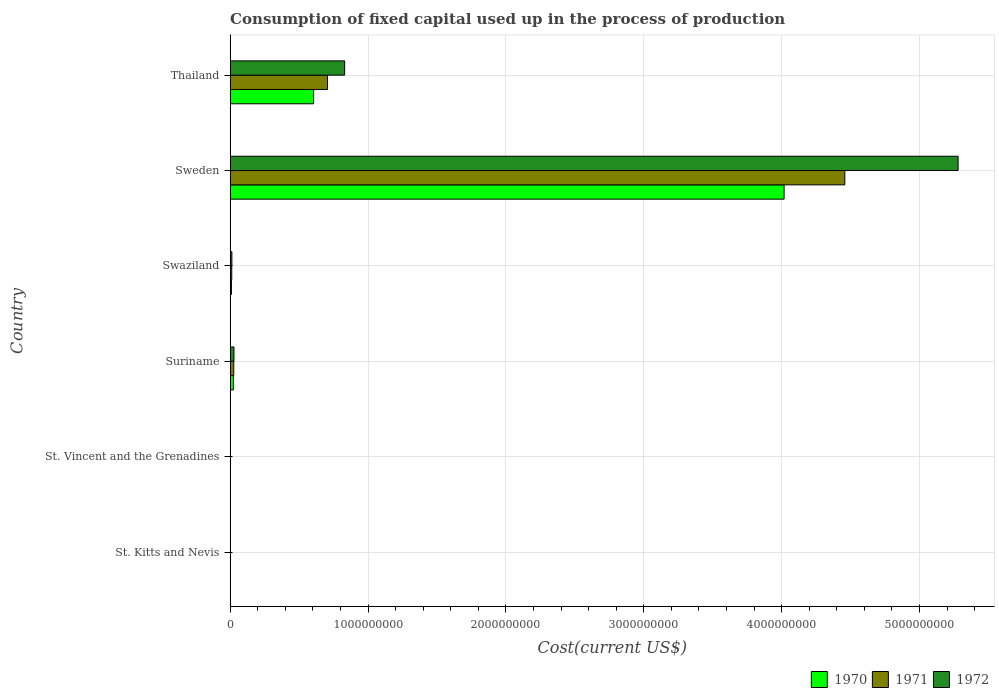How many different coloured bars are there?
Ensure brevity in your answer.  3. How many groups of bars are there?
Your response must be concise. 6. Are the number of bars per tick equal to the number of legend labels?
Give a very brief answer. Yes. Are the number of bars on each tick of the Y-axis equal?
Ensure brevity in your answer.  Yes. How many bars are there on the 6th tick from the top?
Make the answer very short. 3. What is the label of the 6th group of bars from the top?
Provide a short and direct response. St. Kitts and Nevis. What is the amount consumed in the process of production in 1971 in St. Kitts and Nevis?
Give a very brief answer. 1.05e+06. Across all countries, what is the maximum amount consumed in the process of production in 1971?
Your answer should be compact. 4.46e+09. Across all countries, what is the minimum amount consumed in the process of production in 1971?
Offer a terse response. 4.77e+05. In which country was the amount consumed in the process of production in 1970 minimum?
Your answer should be compact. St. Kitts and Nevis. What is the total amount consumed in the process of production in 1972 in the graph?
Keep it short and to the point. 6.15e+09. What is the difference between the amount consumed in the process of production in 1970 in Suriname and that in Sweden?
Offer a terse response. -3.99e+09. What is the difference between the amount consumed in the process of production in 1972 in St. Kitts and Nevis and the amount consumed in the process of production in 1971 in Swaziland?
Provide a short and direct response. -9.95e+06. What is the average amount consumed in the process of production in 1970 per country?
Your answer should be very brief. 7.76e+08. What is the difference between the amount consumed in the process of production in 1972 and amount consumed in the process of production in 1971 in Suriname?
Your answer should be compact. 1.60e+06. In how many countries, is the amount consumed in the process of production in 1970 greater than 600000000 US$?
Your answer should be very brief. 2. What is the ratio of the amount consumed in the process of production in 1970 in St. Kitts and Nevis to that in Sweden?
Give a very brief answer. 0. What is the difference between the highest and the second highest amount consumed in the process of production in 1972?
Your answer should be compact. 4.45e+09. What is the difference between the highest and the lowest amount consumed in the process of production in 1972?
Your response must be concise. 5.28e+09. In how many countries, is the amount consumed in the process of production in 1970 greater than the average amount consumed in the process of production in 1970 taken over all countries?
Provide a short and direct response. 1. Is the sum of the amount consumed in the process of production in 1971 in St. Vincent and the Grenadines and Suriname greater than the maximum amount consumed in the process of production in 1972 across all countries?
Provide a short and direct response. No. How many countries are there in the graph?
Make the answer very short. 6. Are the values on the major ticks of X-axis written in scientific E-notation?
Give a very brief answer. No. Where does the legend appear in the graph?
Make the answer very short. Bottom right. How many legend labels are there?
Your answer should be compact. 3. How are the legend labels stacked?
Your response must be concise. Horizontal. What is the title of the graph?
Your answer should be compact. Consumption of fixed capital used up in the process of production. What is the label or title of the X-axis?
Your answer should be compact. Cost(current US$). What is the Cost(current US$) of 1970 in St. Kitts and Nevis?
Provide a succinct answer. 8.25e+05. What is the Cost(current US$) of 1971 in St. Kitts and Nevis?
Provide a short and direct response. 1.05e+06. What is the Cost(current US$) in 1972 in St. Kitts and Nevis?
Make the answer very short. 1.35e+06. What is the Cost(current US$) of 1970 in St. Vincent and the Grenadines?
Offer a terse response. 9.66e+05. What is the Cost(current US$) of 1971 in St. Vincent and the Grenadines?
Give a very brief answer. 4.77e+05. What is the Cost(current US$) in 1972 in St. Vincent and the Grenadines?
Provide a short and direct response. 5.25e+05. What is the Cost(current US$) of 1970 in Suriname?
Offer a terse response. 2.35e+07. What is the Cost(current US$) of 1971 in Suriname?
Ensure brevity in your answer.  2.58e+07. What is the Cost(current US$) of 1972 in Suriname?
Make the answer very short. 2.74e+07. What is the Cost(current US$) in 1970 in Swaziland?
Your answer should be very brief. 9.10e+06. What is the Cost(current US$) of 1971 in Swaziland?
Give a very brief answer. 1.13e+07. What is the Cost(current US$) of 1972 in Swaziland?
Make the answer very short. 1.23e+07. What is the Cost(current US$) of 1970 in Sweden?
Ensure brevity in your answer.  4.02e+09. What is the Cost(current US$) in 1971 in Sweden?
Provide a succinct answer. 4.46e+09. What is the Cost(current US$) of 1972 in Sweden?
Keep it short and to the point. 5.28e+09. What is the Cost(current US$) in 1970 in Thailand?
Offer a very short reply. 6.05e+08. What is the Cost(current US$) of 1971 in Thailand?
Your answer should be very brief. 7.06e+08. What is the Cost(current US$) of 1972 in Thailand?
Make the answer very short. 8.30e+08. Across all countries, what is the maximum Cost(current US$) of 1970?
Give a very brief answer. 4.02e+09. Across all countries, what is the maximum Cost(current US$) of 1971?
Keep it short and to the point. 4.46e+09. Across all countries, what is the maximum Cost(current US$) in 1972?
Your answer should be compact. 5.28e+09. Across all countries, what is the minimum Cost(current US$) in 1970?
Provide a succinct answer. 8.25e+05. Across all countries, what is the minimum Cost(current US$) of 1971?
Offer a very short reply. 4.77e+05. Across all countries, what is the minimum Cost(current US$) in 1972?
Your answer should be very brief. 5.25e+05. What is the total Cost(current US$) of 1970 in the graph?
Keep it short and to the point. 4.66e+09. What is the total Cost(current US$) in 1971 in the graph?
Offer a very short reply. 5.20e+09. What is the total Cost(current US$) of 1972 in the graph?
Offer a very short reply. 6.15e+09. What is the difference between the Cost(current US$) of 1970 in St. Kitts and Nevis and that in St. Vincent and the Grenadines?
Give a very brief answer. -1.41e+05. What is the difference between the Cost(current US$) of 1971 in St. Kitts and Nevis and that in St. Vincent and the Grenadines?
Provide a succinct answer. 5.71e+05. What is the difference between the Cost(current US$) of 1972 in St. Kitts and Nevis and that in St. Vincent and the Grenadines?
Your answer should be compact. 8.24e+05. What is the difference between the Cost(current US$) of 1970 in St. Kitts and Nevis and that in Suriname?
Your answer should be very brief. -2.26e+07. What is the difference between the Cost(current US$) of 1971 in St. Kitts and Nevis and that in Suriname?
Keep it short and to the point. -2.48e+07. What is the difference between the Cost(current US$) in 1972 in St. Kitts and Nevis and that in Suriname?
Provide a succinct answer. -2.61e+07. What is the difference between the Cost(current US$) in 1970 in St. Kitts and Nevis and that in Swaziland?
Your answer should be very brief. -8.28e+06. What is the difference between the Cost(current US$) in 1971 in St. Kitts and Nevis and that in Swaziland?
Your answer should be compact. -1.03e+07. What is the difference between the Cost(current US$) of 1972 in St. Kitts and Nevis and that in Swaziland?
Make the answer very short. -1.09e+07. What is the difference between the Cost(current US$) of 1970 in St. Kitts and Nevis and that in Sweden?
Make the answer very short. -4.02e+09. What is the difference between the Cost(current US$) in 1971 in St. Kitts and Nevis and that in Sweden?
Your response must be concise. -4.46e+09. What is the difference between the Cost(current US$) in 1972 in St. Kitts and Nevis and that in Sweden?
Provide a short and direct response. -5.28e+09. What is the difference between the Cost(current US$) of 1970 in St. Kitts and Nevis and that in Thailand?
Make the answer very short. -6.04e+08. What is the difference between the Cost(current US$) of 1971 in St. Kitts and Nevis and that in Thailand?
Make the answer very short. -7.05e+08. What is the difference between the Cost(current US$) of 1972 in St. Kitts and Nevis and that in Thailand?
Offer a terse response. -8.29e+08. What is the difference between the Cost(current US$) in 1970 in St. Vincent and the Grenadines and that in Suriname?
Make the answer very short. -2.25e+07. What is the difference between the Cost(current US$) in 1971 in St. Vincent and the Grenadines and that in Suriname?
Provide a short and direct response. -2.53e+07. What is the difference between the Cost(current US$) in 1972 in St. Vincent and the Grenadines and that in Suriname?
Keep it short and to the point. -2.69e+07. What is the difference between the Cost(current US$) in 1970 in St. Vincent and the Grenadines and that in Swaziland?
Your response must be concise. -8.14e+06. What is the difference between the Cost(current US$) of 1971 in St. Vincent and the Grenadines and that in Swaziland?
Make the answer very short. -1.08e+07. What is the difference between the Cost(current US$) in 1972 in St. Vincent and the Grenadines and that in Swaziland?
Make the answer very short. -1.18e+07. What is the difference between the Cost(current US$) in 1970 in St. Vincent and the Grenadines and that in Sweden?
Your answer should be compact. -4.02e+09. What is the difference between the Cost(current US$) of 1971 in St. Vincent and the Grenadines and that in Sweden?
Give a very brief answer. -4.46e+09. What is the difference between the Cost(current US$) in 1972 in St. Vincent and the Grenadines and that in Sweden?
Your answer should be compact. -5.28e+09. What is the difference between the Cost(current US$) of 1970 in St. Vincent and the Grenadines and that in Thailand?
Your answer should be compact. -6.04e+08. What is the difference between the Cost(current US$) of 1971 in St. Vincent and the Grenadines and that in Thailand?
Make the answer very short. -7.06e+08. What is the difference between the Cost(current US$) of 1972 in St. Vincent and the Grenadines and that in Thailand?
Offer a terse response. -8.30e+08. What is the difference between the Cost(current US$) in 1970 in Suriname and that in Swaziland?
Make the answer very short. 1.44e+07. What is the difference between the Cost(current US$) of 1971 in Suriname and that in Swaziland?
Give a very brief answer. 1.45e+07. What is the difference between the Cost(current US$) in 1972 in Suriname and that in Swaziland?
Your response must be concise. 1.51e+07. What is the difference between the Cost(current US$) of 1970 in Suriname and that in Sweden?
Offer a very short reply. -3.99e+09. What is the difference between the Cost(current US$) of 1971 in Suriname and that in Sweden?
Your response must be concise. -4.43e+09. What is the difference between the Cost(current US$) of 1972 in Suriname and that in Sweden?
Ensure brevity in your answer.  -5.25e+09. What is the difference between the Cost(current US$) of 1970 in Suriname and that in Thailand?
Provide a succinct answer. -5.82e+08. What is the difference between the Cost(current US$) of 1971 in Suriname and that in Thailand?
Your response must be concise. -6.80e+08. What is the difference between the Cost(current US$) in 1972 in Suriname and that in Thailand?
Your answer should be very brief. -8.03e+08. What is the difference between the Cost(current US$) in 1970 in Swaziland and that in Sweden?
Give a very brief answer. -4.01e+09. What is the difference between the Cost(current US$) of 1971 in Swaziland and that in Sweden?
Provide a short and direct response. -4.45e+09. What is the difference between the Cost(current US$) in 1972 in Swaziland and that in Sweden?
Ensure brevity in your answer.  -5.27e+09. What is the difference between the Cost(current US$) in 1970 in Swaziland and that in Thailand?
Make the answer very short. -5.96e+08. What is the difference between the Cost(current US$) of 1971 in Swaziland and that in Thailand?
Offer a very short reply. -6.95e+08. What is the difference between the Cost(current US$) of 1972 in Swaziland and that in Thailand?
Ensure brevity in your answer.  -8.18e+08. What is the difference between the Cost(current US$) of 1970 in Sweden and that in Thailand?
Ensure brevity in your answer.  3.41e+09. What is the difference between the Cost(current US$) of 1971 in Sweden and that in Thailand?
Offer a very short reply. 3.75e+09. What is the difference between the Cost(current US$) in 1972 in Sweden and that in Thailand?
Your answer should be compact. 4.45e+09. What is the difference between the Cost(current US$) in 1970 in St. Kitts and Nevis and the Cost(current US$) in 1971 in St. Vincent and the Grenadines?
Your answer should be compact. 3.49e+05. What is the difference between the Cost(current US$) of 1970 in St. Kitts and Nevis and the Cost(current US$) of 1972 in St. Vincent and the Grenadines?
Provide a short and direct response. 3.00e+05. What is the difference between the Cost(current US$) of 1971 in St. Kitts and Nevis and the Cost(current US$) of 1972 in St. Vincent and the Grenadines?
Provide a short and direct response. 5.22e+05. What is the difference between the Cost(current US$) of 1970 in St. Kitts and Nevis and the Cost(current US$) of 1971 in Suriname?
Provide a succinct answer. -2.50e+07. What is the difference between the Cost(current US$) of 1970 in St. Kitts and Nevis and the Cost(current US$) of 1972 in Suriname?
Provide a succinct answer. -2.66e+07. What is the difference between the Cost(current US$) in 1971 in St. Kitts and Nevis and the Cost(current US$) in 1972 in Suriname?
Your answer should be very brief. -2.64e+07. What is the difference between the Cost(current US$) in 1970 in St. Kitts and Nevis and the Cost(current US$) in 1971 in Swaziland?
Your answer should be very brief. -1.05e+07. What is the difference between the Cost(current US$) in 1970 in St. Kitts and Nevis and the Cost(current US$) in 1972 in Swaziland?
Your response must be concise. -1.15e+07. What is the difference between the Cost(current US$) of 1971 in St. Kitts and Nevis and the Cost(current US$) of 1972 in Swaziland?
Your response must be concise. -1.12e+07. What is the difference between the Cost(current US$) of 1970 in St. Kitts and Nevis and the Cost(current US$) of 1971 in Sweden?
Ensure brevity in your answer.  -4.46e+09. What is the difference between the Cost(current US$) in 1970 in St. Kitts and Nevis and the Cost(current US$) in 1972 in Sweden?
Your answer should be very brief. -5.28e+09. What is the difference between the Cost(current US$) in 1971 in St. Kitts and Nevis and the Cost(current US$) in 1972 in Sweden?
Make the answer very short. -5.28e+09. What is the difference between the Cost(current US$) in 1970 in St. Kitts and Nevis and the Cost(current US$) in 1971 in Thailand?
Your response must be concise. -7.05e+08. What is the difference between the Cost(current US$) in 1970 in St. Kitts and Nevis and the Cost(current US$) in 1972 in Thailand?
Offer a terse response. -8.29e+08. What is the difference between the Cost(current US$) of 1971 in St. Kitts and Nevis and the Cost(current US$) of 1972 in Thailand?
Your answer should be compact. -8.29e+08. What is the difference between the Cost(current US$) of 1970 in St. Vincent and the Grenadines and the Cost(current US$) of 1971 in Suriname?
Ensure brevity in your answer.  -2.48e+07. What is the difference between the Cost(current US$) of 1970 in St. Vincent and the Grenadines and the Cost(current US$) of 1972 in Suriname?
Your response must be concise. -2.64e+07. What is the difference between the Cost(current US$) in 1971 in St. Vincent and the Grenadines and the Cost(current US$) in 1972 in Suriname?
Provide a short and direct response. -2.69e+07. What is the difference between the Cost(current US$) of 1970 in St. Vincent and the Grenadines and the Cost(current US$) of 1971 in Swaziland?
Provide a short and direct response. -1.03e+07. What is the difference between the Cost(current US$) in 1970 in St. Vincent and the Grenadines and the Cost(current US$) in 1972 in Swaziland?
Your answer should be compact. -1.13e+07. What is the difference between the Cost(current US$) of 1971 in St. Vincent and the Grenadines and the Cost(current US$) of 1972 in Swaziland?
Make the answer very short. -1.18e+07. What is the difference between the Cost(current US$) in 1970 in St. Vincent and the Grenadines and the Cost(current US$) in 1971 in Sweden?
Keep it short and to the point. -4.46e+09. What is the difference between the Cost(current US$) in 1970 in St. Vincent and the Grenadines and the Cost(current US$) in 1972 in Sweden?
Provide a short and direct response. -5.28e+09. What is the difference between the Cost(current US$) in 1971 in St. Vincent and the Grenadines and the Cost(current US$) in 1972 in Sweden?
Keep it short and to the point. -5.28e+09. What is the difference between the Cost(current US$) in 1970 in St. Vincent and the Grenadines and the Cost(current US$) in 1971 in Thailand?
Keep it short and to the point. -7.05e+08. What is the difference between the Cost(current US$) of 1970 in St. Vincent and the Grenadines and the Cost(current US$) of 1972 in Thailand?
Provide a succinct answer. -8.29e+08. What is the difference between the Cost(current US$) in 1971 in St. Vincent and the Grenadines and the Cost(current US$) in 1972 in Thailand?
Keep it short and to the point. -8.30e+08. What is the difference between the Cost(current US$) in 1970 in Suriname and the Cost(current US$) in 1971 in Swaziland?
Your answer should be compact. 1.22e+07. What is the difference between the Cost(current US$) of 1970 in Suriname and the Cost(current US$) of 1972 in Swaziland?
Make the answer very short. 1.12e+07. What is the difference between the Cost(current US$) of 1971 in Suriname and the Cost(current US$) of 1972 in Swaziland?
Provide a short and direct response. 1.35e+07. What is the difference between the Cost(current US$) in 1970 in Suriname and the Cost(current US$) in 1971 in Sweden?
Your answer should be compact. -4.44e+09. What is the difference between the Cost(current US$) in 1970 in Suriname and the Cost(current US$) in 1972 in Sweden?
Keep it short and to the point. -5.26e+09. What is the difference between the Cost(current US$) in 1971 in Suriname and the Cost(current US$) in 1972 in Sweden?
Make the answer very short. -5.25e+09. What is the difference between the Cost(current US$) in 1970 in Suriname and the Cost(current US$) in 1971 in Thailand?
Offer a terse response. -6.83e+08. What is the difference between the Cost(current US$) of 1970 in Suriname and the Cost(current US$) of 1972 in Thailand?
Provide a short and direct response. -8.07e+08. What is the difference between the Cost(current US$) of 1971 in Suriname and the Cost(current US$) of 1972 in Thailand?
Provide a short and direct response. -8.04e+08. What is the difference between the Cost(current US$) in 1970 in Swaziland and the Cost(current US$) in 1971 in Sweden?
Your response must be concise. -4.45e+09. What is the difference between the Cost(current US$) of 1970 in Swaziland and the Cost(current US$) of 1972 in Sweden?
Your answer should be compact. -5.27e+09. What is the difference between the Cost(current US$) in 1971 in Swaziland and the Cost(current US$) in 1972 in Sweden?
Provide a succinct answer. -5.27e+09. What is the difference between the Cost(current US$) in 1970 in Swaziland and the Cost(current US$) in 1971 in Thailand?
Your response must be concise. -6.97e+08. What is the difference between the Cost(current US$) of 1970 in Swaziland and the Cost(current US$) of 1972 in Thailand?
Offer a very short reply. -8.21e+08. What is the difference between the Cost(current US$) in 1971 in Swaziland and the Cost(current US$) in 1972 in Thailand?
Ensure brevity in your answer.  -8.19e+08. What is the difference between the Cost(current US$) of 1970 in Sweden and the Cost(current US$) of 1971 in Thailand?
Keep it short and to the point. 3.31e+09. What is the difference between the Cost(current US$) of 1970 in Sweden and the Cost(current US$) of 1972 in Thailand?
Your response must be concise. 3.19e+09. What is the difference between the Cost(current US$) of 1971 in Sweden and the Cost(current US$) of 1972 in Thailand?
Keep it short and to the point. 3.63e+09. What is the average Cost(current US$) of 1970 per country?
Make the answer very short. 7.76e+08. What is the average Cost(current US$) in 1971 per country?
Ensure brevity in your answer.  8.67e+08. What is the average Cost(current US$) of 1972 per country?
Offer a terse response. 1.03e+09. What is the difference between the Cost(current US$) of 1970 and Cost(current US$) of 1971 in St. Kitts and Nevis?
Provide a short and direct response. -2.22e+05. What is the difference between the Cost(current US$) in 1970 and Cost(current US$) in 1972 in St. Kitts and Nevis?
Your response must be concise. -5.24e+05. What is the difference between the Cost(current US$) in 1971 and Cost(current US$) in 1972 in St. Kitts and Nevis?
Offer a terse response. -3.02e+05. What is the difference between the Cost(current US$) of 1970 and Cost(current US$) of 1971 in St. Vincent and the Grenadines?
Provide a short and direct response. 4.89e+05. What is the difference between the Cost(current US$) of 1970 and Cost(current US$) of 1972 in St. Vincent and the Grenadines?
Provide a short and direct response. 4.40e+05. What is the difference between the Cost(current US$) in 1971 and Cost(current US$) in 1972 in St. Vincent and the Grenadines?
Provide a short and direct response. -4.89e+04. What is the difference between the Cost(current US$) in 1970 and Cost(current US$) in 1971 in Suriname?
Give a very brief answer. -2.35e+06. What is the difference between the Cost(current US$) in 1970 and Cost(current US$) in 1972 in Suriname?
Ensure brevity in your answer.  -3.95e+06. What is the difference between the Cost(current US$) of 1971 and Cost(current US$) of 1972 in Suriname?
Offer a very short reply. -1.60e+06. What is the difference between the Cost(current US$) in 1970 and Cost(current US$) in 1971 in Swaziland?
Offer a very short reply. -2.20e+06. What is the difference between the Cost(current US$) in 1970 and Cost(current US$) in 1972 in Swaziland?
Your answer should be very brief. -3.19e+06. What is the difference between the Cost(current US$) of 1971 and Cost(current US$) of 1972 in Swaziland?
Provide a succinct answer. -9.90e+05. What is the difference between the Cost(current US$) of 1970 and Cost(current US$) of 1971 in Sweden?
Provide a short and direct response. -4.41e+08. What is the difference between the Cost(current US$) in 1970 and Cost(current US$) in 1972 in Sweden?
Your answer should be very brief. -1.26e+09. What is the difference between the Cost(current US$) in 1971 and Cost(current US$) in 1972 in Sweden?
Ensure brevity in your answer.  -8.22e+08. What is the difference between the Cost(current US$) in 1970 and Cost(current US$) in 1971 in Thailand?
Provide a short and direct response. -1.01e+08. What is the difference between the Cost(current US$) in 1970 and Cost(current US$) in 1972 in Thailand?
Provide a succinct answer. -2.25e+08. What is the difference between the Cost(current US$) in 1971 and Cost(current US$) in 1972 in Thailand?
Provide a short and direct response. -1.24e+08. What is the ratio of the Cost(current US$) in 1970 in St. Kitts and Nevis to that in St. Vincent and the Grenadines?
Provide a short and direct response. 0.85. What is the ratio of the Cost(current US$) of 1971 in St. Kitts and Nevis to that in St. Vincent and the Grenadines?
Make the answer very short. 2.2. What is the ratio of the Cost(current US$) of 1972 in St. Kitts and Nevis to that in St. Vincent and the Grenadines?
Offer a very short reply. 2.57. What is the ratio of the Cost(current US$) in 1970 in St. Kitts and Nevis to that in Suriname?
Give a very brief answer. 0.04. What is the ratio of the Cost(current US$) in 1971 in St. Kitts and Nevis to that in Suriname?
Provide a succinct answer. 0.04. What is the ratio of the Cost(current US$) in 1972 in St. Kitts and Nevis to that in Suriname?
Give a very brief answer. 0.05. What is the ratio of the Cost(current US$) of 1970 in St. Kitts and Nevis to that in Swaziland?
Provide a short and direct response. 0.09. What is the ratio of the Cost(current US$) in 1971 in St. Kitts and Nevis to that in Swaziland?
Your answer should be compact. 0.09. What is the ratio of the Cost(current US$) of 1972 in St. Kitts and Nevis to that in Swaziland?
Your answer should be very brief. 0.11. What is the ratio of the Cost(current US$) of 1970 in St. Kitts and Nevis to that in Sweden?
Provide a short and direct response. 0. What is the ratio of the Cost(current US$) in 1970 in St. Kitts and Nevis to that in Thailand?
Your answer should be very brief. 0. What is the ratio of the Cost(current US$) in 1971 in St. Kitts and Nevis to that in Thailand?
Give a very brief answer. 0. What is the ratio of the Cost(current US$) in 1972 in St. Kitts and Nevis to that in Thailand?
Keep it short and to the point. 0. What is the ratio of the Cost(current US$) of 1970 in St. Vincent and the Grenadines to that in Suriname?
Keep it short and to the point. 0.04. What is the ratio of the Cost(current US$) in 1971 in St. Vincent and the Grenadines to that in Suriname?
Keep it short and to the point. 0.02. What is the ratio of the Cost(current US$) of 1972 in St. Vincent and the Grenadines to that in Suriname?
Keep it short and to the point. 0.02. What is the ratio of the Cost(current US$) of 1970 in St. Vincent and the Grenadines to that in Swaziland?
Your answer should be very brief. 0.11. What is the ratio of the Cost(current US$) in 1971 in St. Vincent and the Grenadines to that in Swaziland?
Make the answer very short. 0.04. What is the ratio of the Cost(current US$) in 1972 in St. Vincent and the Grenadines to that in Swaziland?
Your answer should be very brief. 0.04. What is the ratio of the Cost(current US$) in 1970 in St. Vincent and the Grenadines to that in Sweden?
Provide a short and direct response. 0. What is the ratio of the Cost(current US$) of 1972 in St. Vincent and the Grenadines to that in Sweden?
Offer a very short reply. 0. What is the ratio of the Cost(current US$) of 1970 in St. Vincent and the Grenadines to that in Thailand?
Provide a short and direct response. 0. What is the ratio of the Cost(current US$) of 1971 in St. Vincent and the Grenadines to that in Thailand?
Ensure brevity in your answer.  0. What is the ratio of the Cost(current US$) in 1972 in St. Vincent and the Grenadines to that in Thailand?
Make the answer very short. 0. What is the ratio of the Cost(current US$) in 1970 in Suriname to that in Swaziland?
Offer a terse response. 2.58. What is the ratio of the Cost(current US$) in 1971 in Suriname to that in Swaziland?
Ensure brevity in your answer.  2.28. What is the ratio of the Cost(current US$) of 1972 in Suriname to that in Swaziland?
Keep it short and to the point. 2.23. What is the ratio of the Cost(current US$) in 1970 in Suriname to that in Sweden?
Your response must be concise. 0.01. What is the ratio of the Cost(current US$) of 1971 in Suriname to that in Sweden?
Provide a short and direct response. 0.01. What is the ratio of the Cost(current US$) in 1972 in Suriname to that in Sweden?
Ensure brevity in your answer.  0.01. What is the ratio of the Cost(current US$) of 1970 in Suriname to that in Thailand?
Offer a terse response. 0.04. What is the ratio of the Cost(current US$) of 1971 in Suriname to that in Thailand?
Your answer should be compact. 0.04. What is the ratio of the Cost(current US$) of 1972 in Suriname to that in Thailand?
Your answer should be very brief. 0.03. What is the ratio of the Cost(current US$) of 1970 in Swaziland to that in Sweden?
Provide a succinct answer. 0. What is the ratio of the Cost(current US$) of 1971 in Swaziland to that in Sweden?
Provide a succinct answer. 0. What is the ratio of the Cost(current US$) of 1972 in Swaziland to that in Sweden?
Offer a very short reply. 0. What is the ratio of the Cost(current US$) in 1970 in Swaziland to that in Thailand?
Your response must be concise. 0.01. What is the ratio of the Cost(current US$) of 1971 in Swaziland to that in Thailand?
Provide a short and direct response. 0.02. What is the ratio of the Cost(current US$) in 1972 in Swaziland to that in Thailand?
Make the answer very short. 0.01. What is the ratio of the Cost(current US$) of 1970 in Sweden to that in Thailand?
Ensure brevity in your answer.  6.64. What is the ratio of the Cost(current US$) of 1971 in Sweden to that in Thailand?
Offer a very short reply. 6.31. What is the ratio of the Cost(current US$) in 1972 in Sweden to that in Thailand?
Your answer should be very brief. 6.36. What is the difference between the highest and the second highest Cost(current US$) of 1970?
Make the answer very short. 3.41e+09. What is the difference between the highest and the second highest Cost(current US$) of 1971?
Give a very brief answer. 3.75e+09. What is the difference between the highest and the second highest Cost(current US$) in 1972?
Make the answer very short. 4.45e+09. What is the difference between the highest and the lowest Cost(current US$) in 1970?
Make the answer very short. 4.02e+09. What is the difference between the highest and the lowest Cost(current US$) in 1971?
Give a very brief answer. 4.46e+09. What is the difference between the highest and the lowest Cost(current US$) in 1972?
Provide a short and direct response. 5.28e+09. 